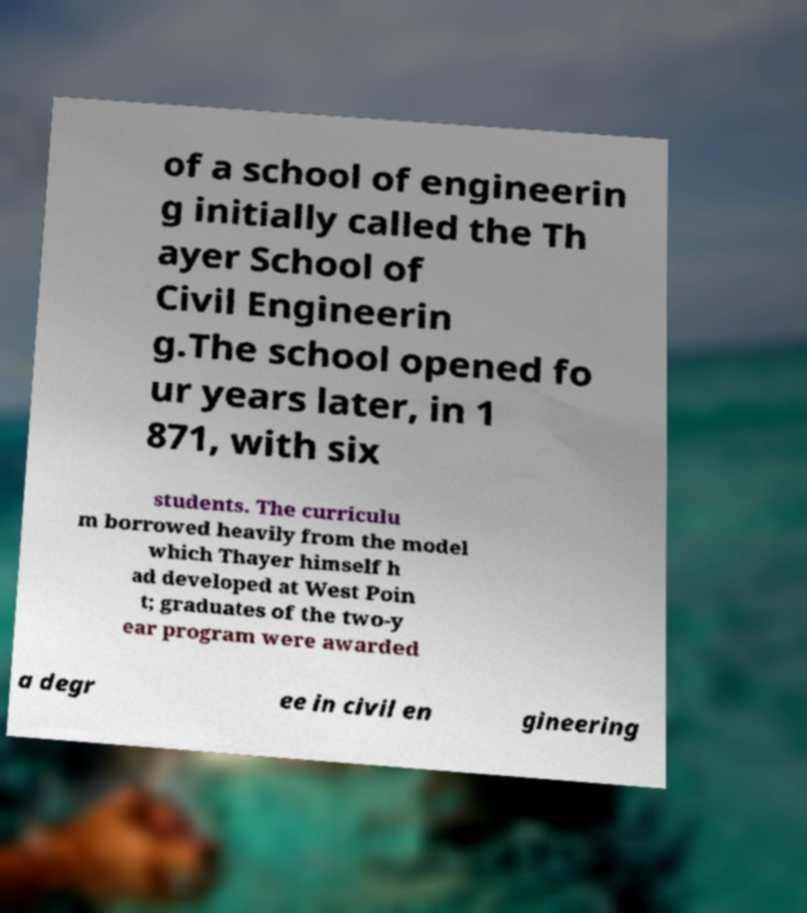What messages or text are displayed in this image? I need them in a readable, typed format. of a school of engineerin g initially called the Th ayer School of Civil Engineerin g.The school opened fo ur years later, in 1 871, with six students. The curriculu m borrowed heavily from the model which Thayer himself h ad developed at West Poin t; graduates of the two-y ear program were awarded a degr ee in civil en gineering 